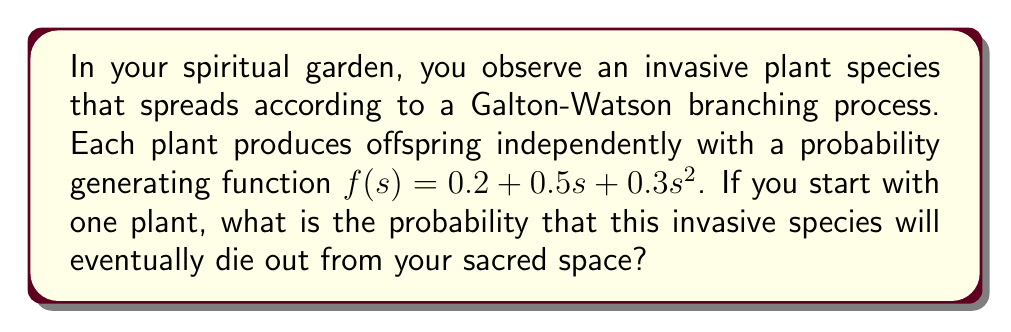Can you solve this math problem? Let's approach this step-by-step:

1) In a Galton-Watson branching process, the extinction probability $q$ is the smallest non-negative root of the equation $s = f(s)$, where $f(s)$ is the probability generating function.

2) In this case, we need to solve:

   $s = 0.2 + 0.5s + 0.3s^2$

3) Rearranging the equation:

   $0.3s^2 + 0.5s + 0.2 - s = 0$
   $0.3s^2 - 0.5s + 0.2 = 0$

4) This is a quadratic equation in the form $as^2 + bs + c = 0$, where:
   $a = 0.3$, $b = -0.5$, and $c = 0.2$

5) We can solve this using the quadratic formula: $s = \frac{-b \pm \sqrt{b^2 - 4ac}}{2a}$

6) Substituting the values:

   $s = \frac{0.5 \pm \sqrt{(-0.5)^2 - 4(0.3)(0.2)}}{2(0.3)}$

   $= \frac{0.5 \pm \sqrt{0.25 - 0.24}}{0.6}$

   $= \frac{0.5 \pm \sqrt{0.01}}{0.6}$

   $= \frac{0.5 \pm 0.1}{0.6}$

7) This gives us two solutions:

   $s_1 = \frac{0.5 + 0.1}{0.6} = 1$

   $s_2 = \frac{0.5 - 0.1}{0.6} = \frac{2}{3}$

8) The extinction probability $q$ is the smallest non-negative root, which is $\frac{2}{3}$.

This means that there is a $\frac{2}{3}$ probability that the invasive species will eventually die out from your spiritual garden.
Answer: $\frac{2}{3}$ 